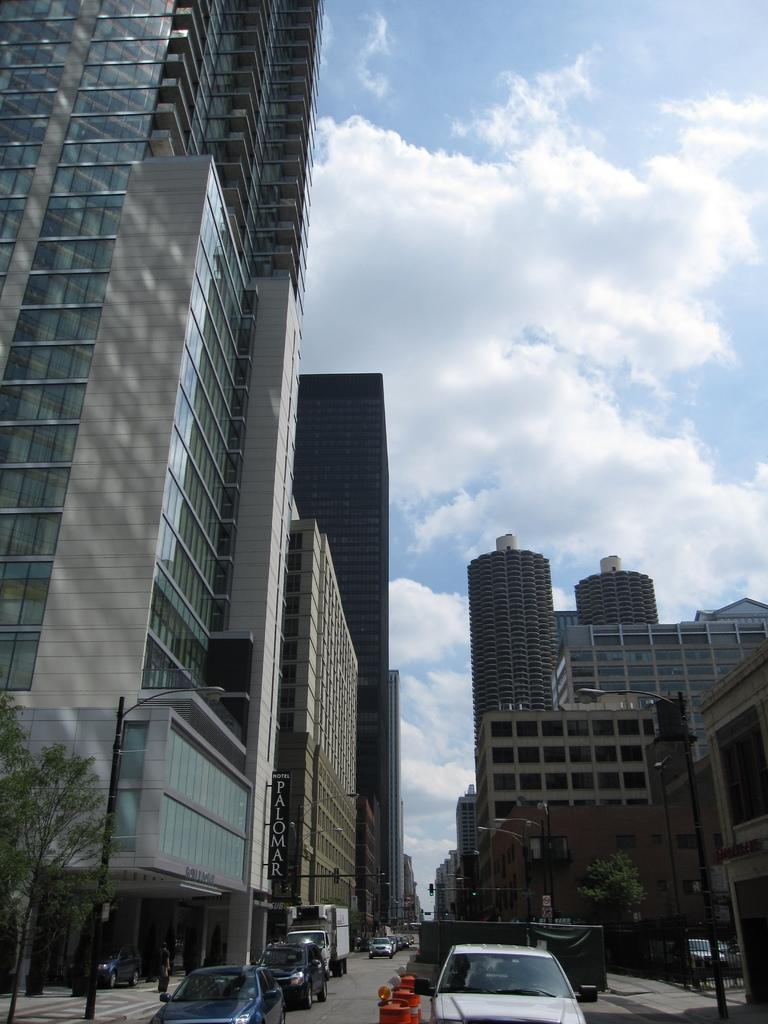What type of structures can be seen in the image? There are buildings in the image. What is located in front of the buildings? There are poles and trees in front of the buildings. Can you describe the vehicle visible in the image? The vehicle is visible in the image, but its specific type is not mentioned in the facts. What is visible at the top of the image? The sky is visible at the top of the image. Where are the trees located in the image? There are trees on the left side of the image. What type of bells can be heard ringing in the image? There are no bells mentioned or depicted in the image, so it is not possible to determine if any bells are ringing. How does the sea affect the buildings in the image? There is no mention of a sea or any body of water in the image, so it is not possible to determine its effect on the buildings. 